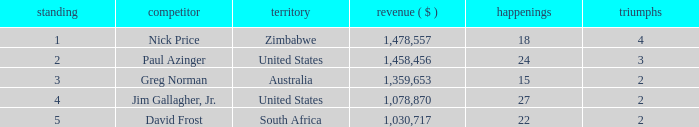How many events are in South Africa? 22.0. 